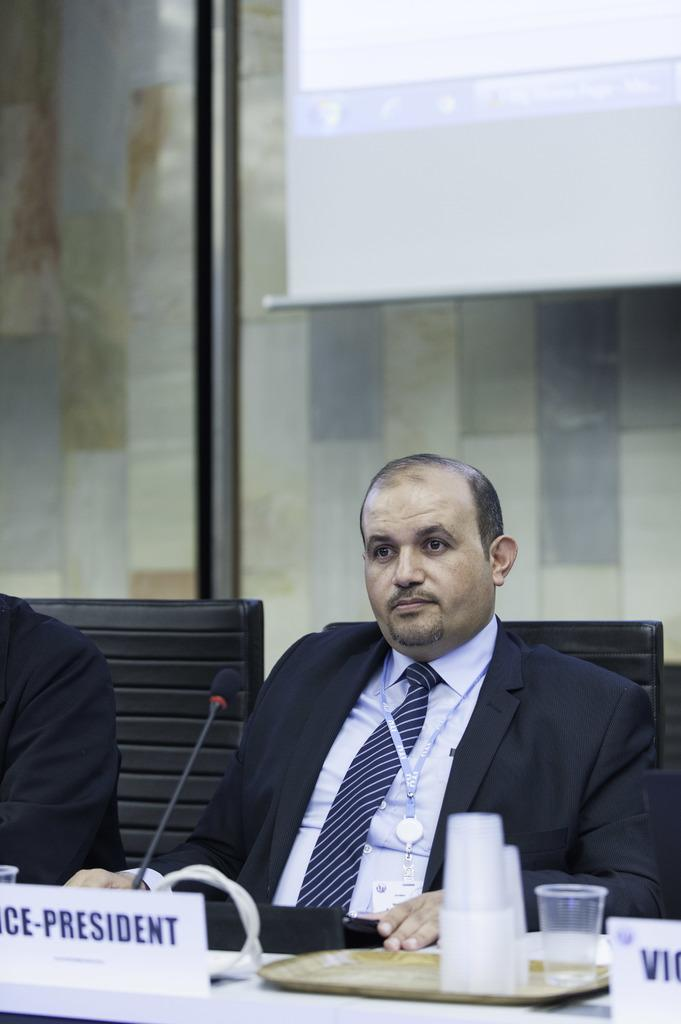Who is the main subject in the foreground of the image? There is a person in the foreground of the image, who is the vice president. What is the vice president doing in the image? The vice president is sitting on a chair. What can be seen in the background of the image? There is a screen visible in the image. What items are present on the table in the image? There are glasses on a plate in the image. Where is the park located in the image? There is no park present in the image. What is the answer to the question being asked on the screen? The image does not provide any information about the content being displayed on the screen, so it is impossible to determine the answer to any question being asked. 